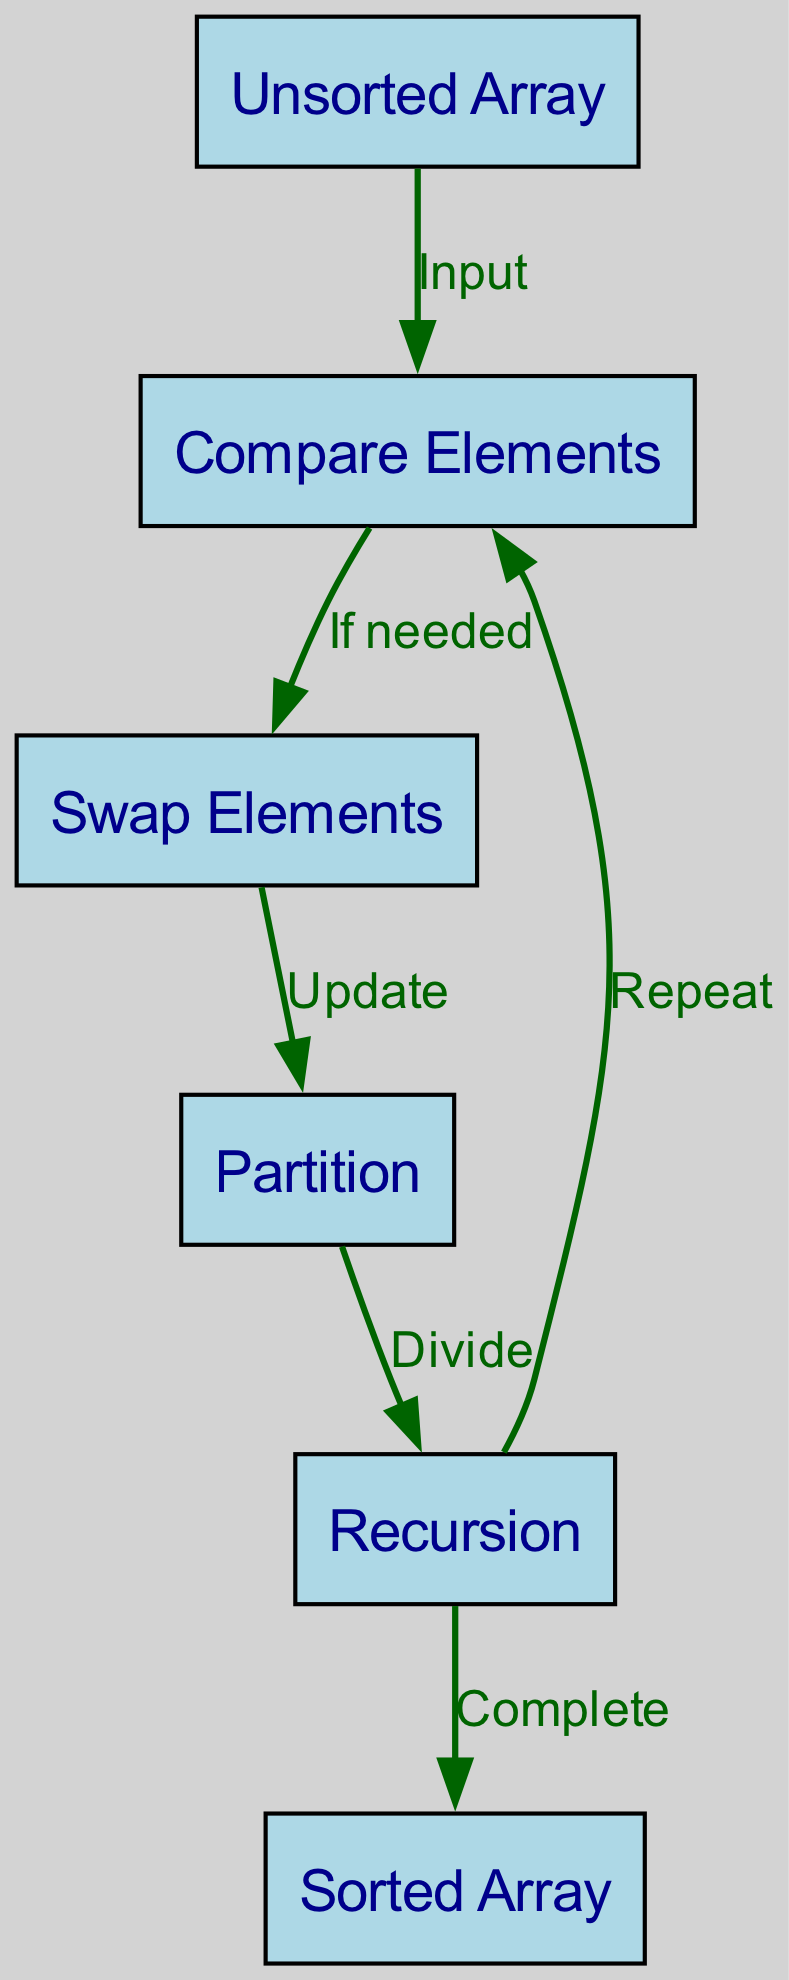What is the first node in the diagram? The first node in the diagram is labeled "Unsorted Array". This is evident as it is the starting point of the data flow in the directed graph.
Answer: Unsorted Array How many nodes are present in the diagram? The diagram contains six nodes, which can be counted directly from the list of nodes provided: Unsorted Array, Compare Elements, Swap Elements, Partition, Recursion, and Sorted Array.
Answer: 6 What is the relationship between "Compare Elements" and "Swap Elements"? The edge shows that "Compare Elements" connects to "Swap Elements" with the label "If needed". This indicates that the comparison may lead to a swap based on certain conditions.
Answer: If needed What does the node "Recursion" lead to? The node "Recursion" has two outgoing edges: one leading back to "Compare Elements" labeled "Repeat" and another leading to "Sorted Array" labeled "Complete". This means it can either continue the process or finish it.
Answer: Compare Elements and Sorted Array What two actions occur after "Partition"? After "Partition", the next actions are "Recursion" and it also flows from "Recursion" back to "Compare Elements". This indicates that the sorting process can recur or can complete.
Answer: Recursion and Repeat In which stage does the algorithm check if elements need to be swapped? The algorithm checks if elements need to be swapped at the "Compare Elements" stage. This is the decision point where the algorithm assesses whether a swap is necessary based on comparisons.
Answer: Compare Elements What is the final output of the sorting algorithm depicted in the diagram? The final output of the sorting algorithm is represented by the node labeled "Sorted Array", which indicates that the sorting process is completed and the result is fully ordered.
Answer: Sorted Array What is indicated by the edge labeled "Divide" coming from "Partition"? The "Divide" label suggests that the "Partition" node is responsible for splitting the data into smaller segments, which is a common operation in sorting algorithms to allow for sorting of sub-arrays or sections.
Answer: Divide What is the purpose of the edge labeled "Update"? The "Update" label indicates that after comparing elements, the algorithm may modify the state of the elements, which usually involves swapping them or changing their order to ensure proper sorting.
Answer: Update 